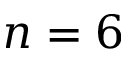Convert formula to latex. <formula><loc_0><loc_0><loc_500><loc_500>n = 6</formula> 